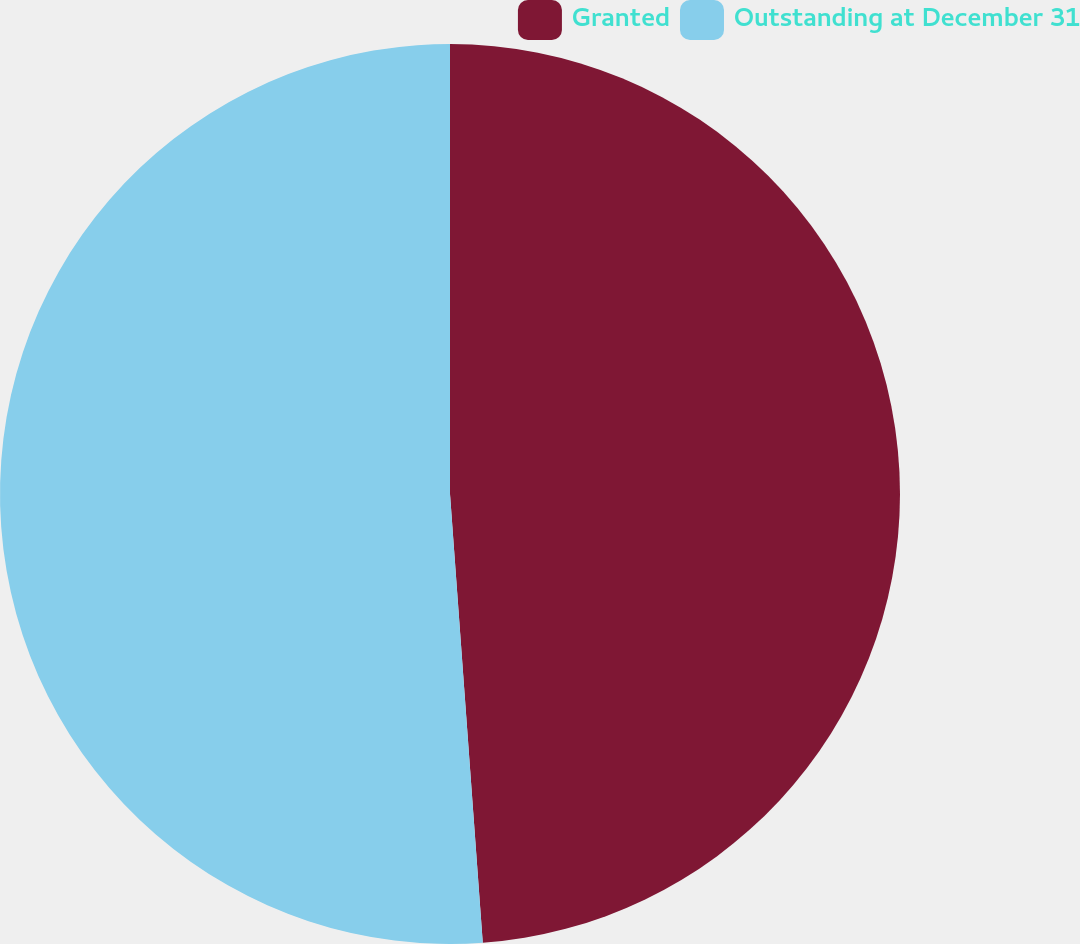Convert chart to OTSL. <chart><loc_0><loc_0><loc_500><loc_500><pie_chart><fcel>Granted<fcel>Outstanding at December 31<nl><fcel>48.84%<fcel>51.16%<nl></chart> 